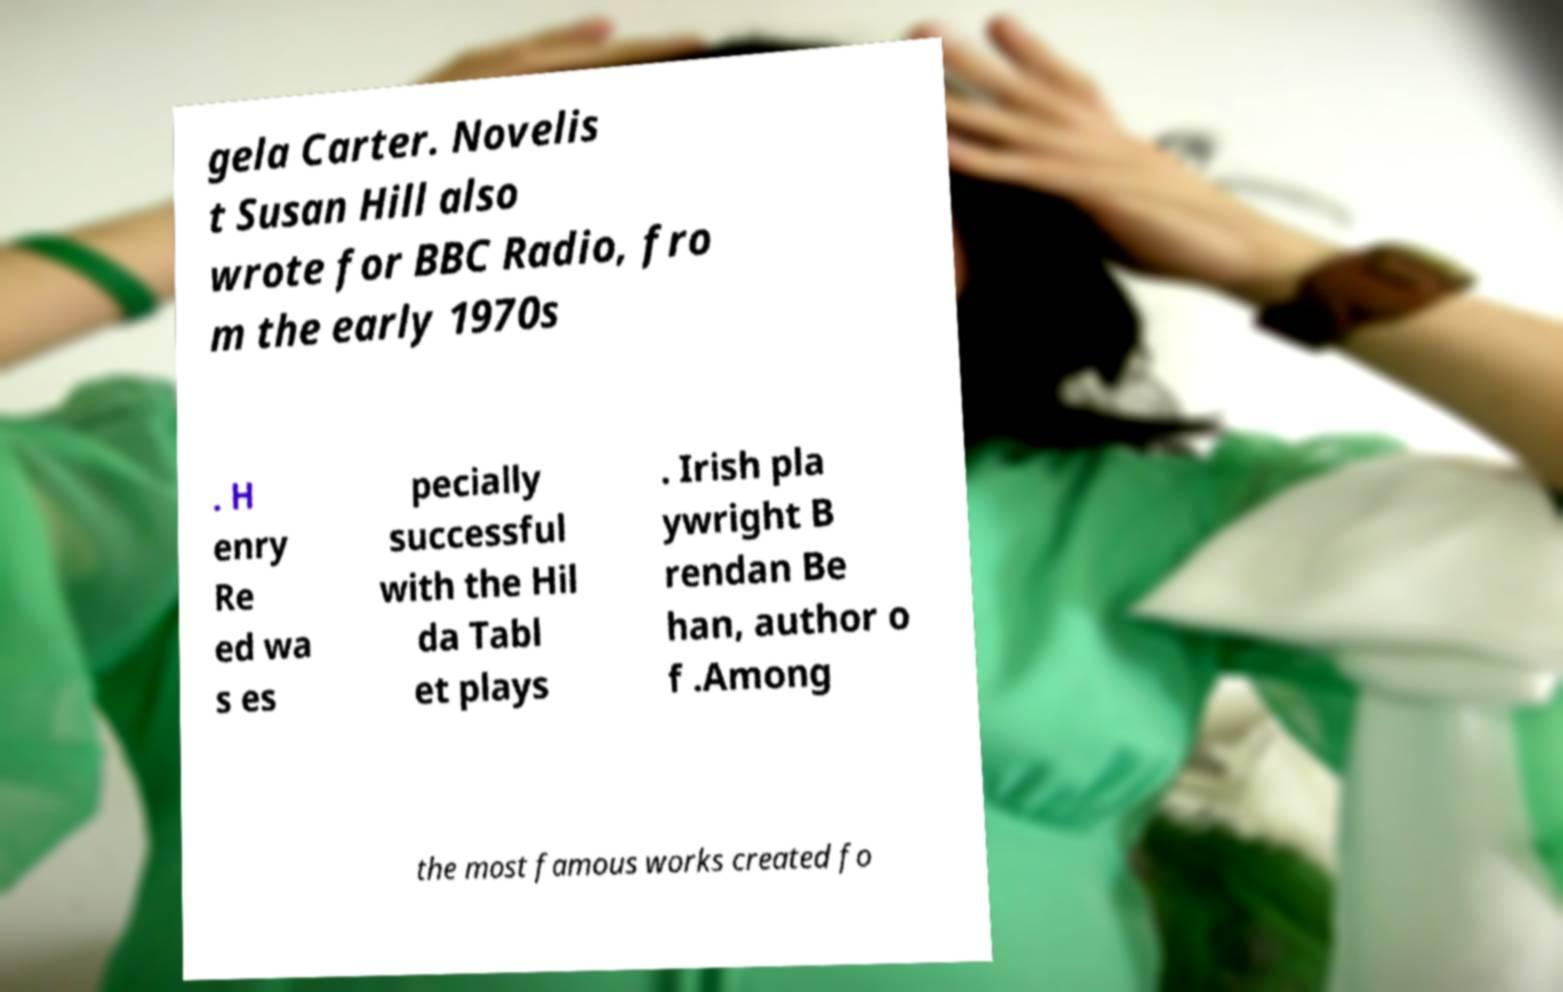Please read and relay the text visible in this image. What does it say? gela Carter. Novelis t Susan Hill also wrote for BBC Radio, fro m the early 1970s . H enry Re ed wa s es pecially successful with the Hil da Tabl et plays . Irish pla ywright B rendan Be han, author o f .Among the most famous works created fo 